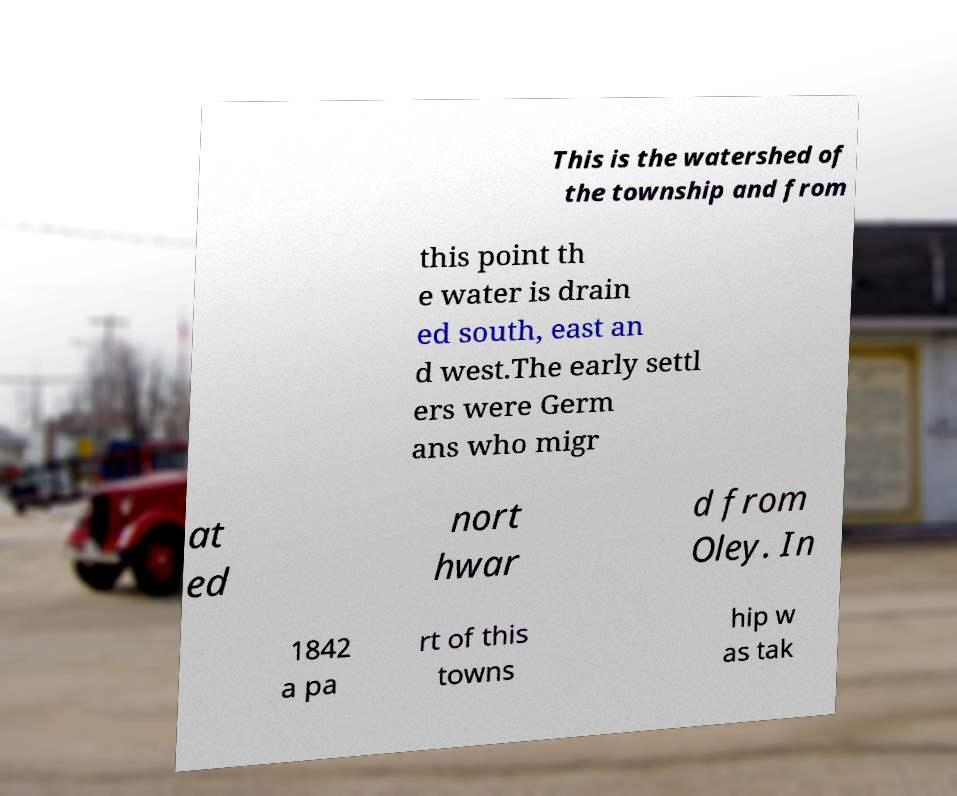I need the written content from this picture converted into text. Can you do that? This is the watershed of the township and from this point th e water is drain ed south, east an d west.The early settl ers were Germ ans who migr at ed nort hwar d from Oley. In 1842 a pa rt of this towns hip w as tak 